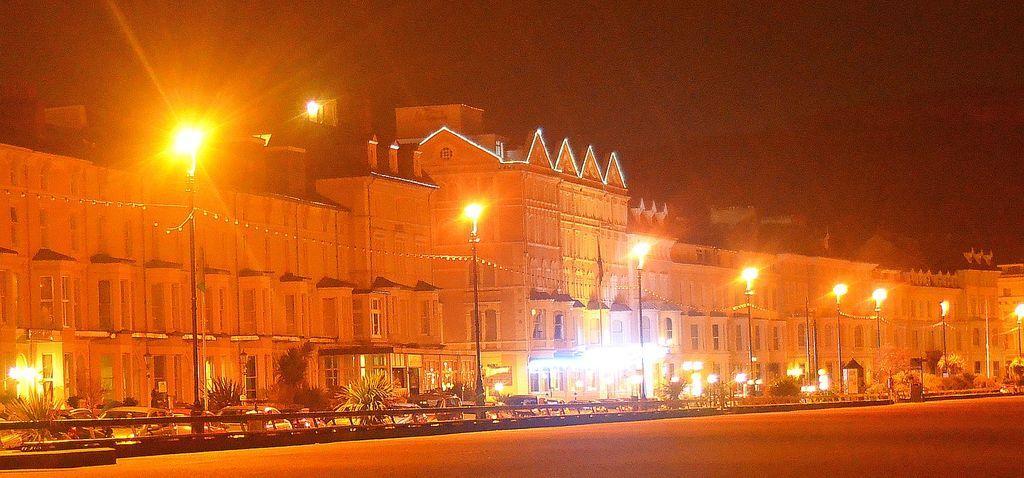Describe this image in one or two sentences. In this picture I can observe a building in the middle of the picture. In front of the building I can observe a road on which some cars are moving. I can observe yellow color street lights in the middle of the picture. In the background there is sky. 